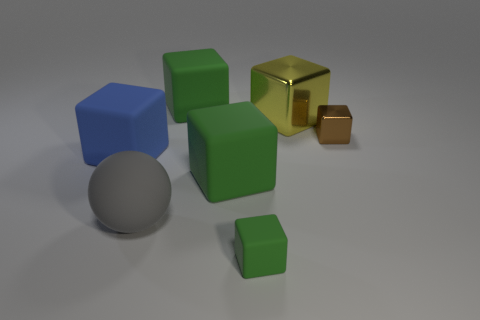The shiny object that is the same size as the rubber ball is what shape?
Offer a very short reply. Cube. Is the small block that is in front of the brown shiny block made of the same material as the yellow block behind the small metal object?
Offer a very short reply. No. There is a green rubber object behind the big metallic object; is there a big matte object that is behind it?
Keep it short and to the point. No. There is another cube that is the same material as the big yellow block; what is its color?
Provide a short and direct response. Brown. Is the number of tiny blocks greater than the number of big yellow shiny objects?
Offer a very short reply. Yes. What number of objects are blocks in front of the large blue cube or blue matte things?
Your answer should be very brief. 3. Is there a blue object that has the same size as the rubber sphere?
Your answer should be compact. Yes. Is the number of small brown cubes less than the number of tiny brown rubber cylinders?
Offer a very short reply. No. How many cubes are either tiny green objects or big yellow things?
Make the answer very short. 2. How many small metal blocks are the same color as the large metal thing?
Offer a very short reply. 0. 